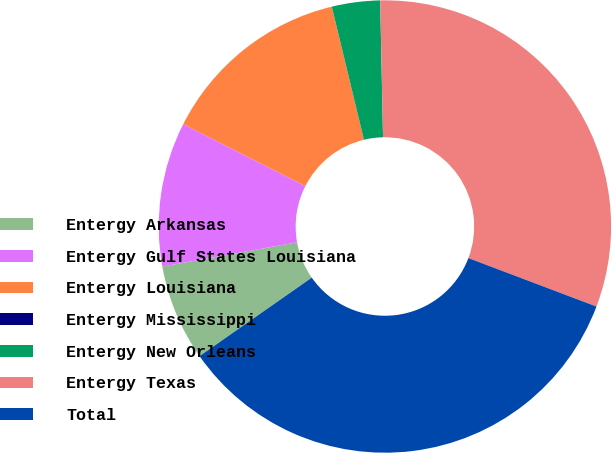Convert chart to OTSL. <chart><loc_0><loc_0><loc_500><loc_500><pie_chart><fcel>Entergy Arkansas<fcel>Entergy Gulf States Louisiana<fcel>Entergy Louisiana<fcel>Entergy Mississippi<fcel>Entergy New Orleans<fcel>Entergy Texas<fcel>Total<nl><fcel>6.88%<fcel>10.31%<fcel>13.75%<fcel>0.0%<fcel>3.44%<fcel>31.09%<fcel>34.53%<nl></chart> 